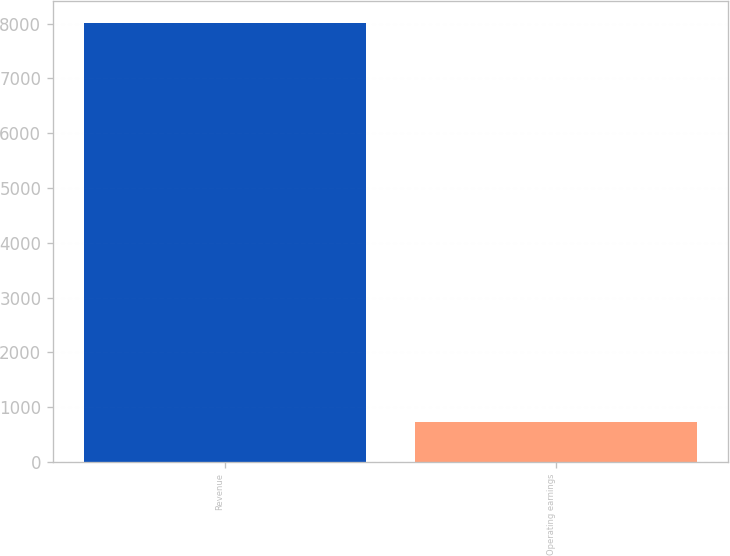Convert chart to OTSL. <chart><loc_0><loc_0><loc_500><loc_500><bar_chart><fcel>Revenue<fcel>Operating earnings<nl><fcel>8013<fcel>728<nl></chart> 